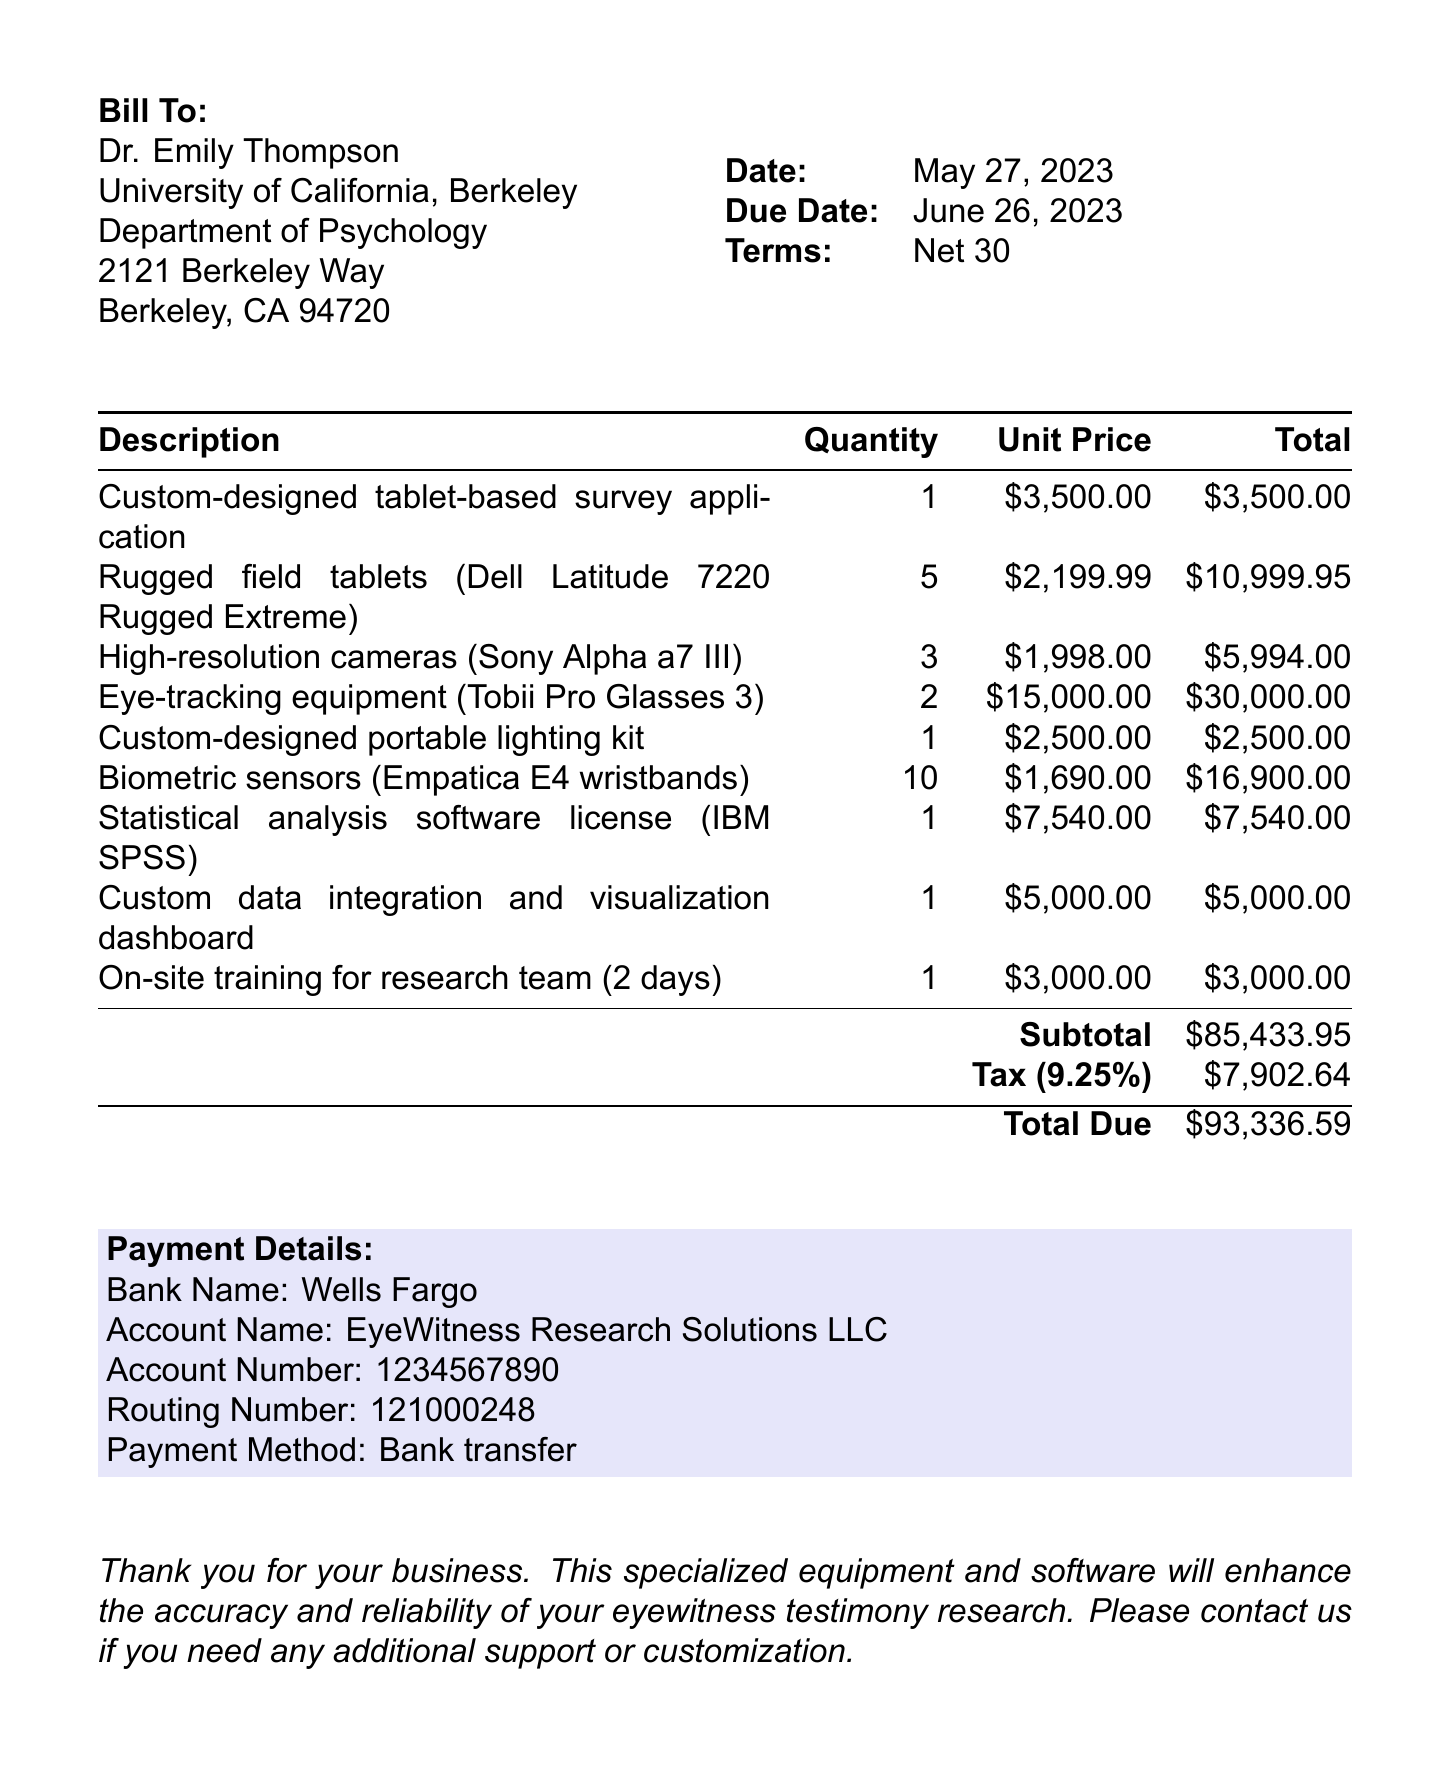What is the invoice number? The invoice number is provided in the document as a unique identifier for the invoice.
Answer: INV-2023-0527 Who is the client for this invoice? The client is specified in the document, including their name and organization.
Answer: Dr. Emily Thompson What is the total amount due? The total amount due is calculated at the end of the invoice, reflecting all charges.
Answer: $93,336.59 How many rugged field tablets were purchased? The document lists the quantity of each item purchased, including rugged field tablets.
Answer: 5 What is the tax rate applied in this invoice? The document states the tax rate applicable to the subtotal in the invoice.
Answer: 9.25% What item has the highest unit price? The invoice lists items along with their unit prices, allowing identification of the most expensive item.
Answer: Eye-tracking equipment (Tobii Pro Glasses 3) What is the payment method listed in the document? The payment method is specified in the payment details section of the invoice.
Answer: Bank transfer What is the subtotal before tax? The subtotal is clearly stated in the invoice, providing the cost of items before tax is added.
Answer: $85,433.95 When is the due date for this invoice? The due date is specified in the document, indicating when payment is expected.
Answer: June 26, 2023 